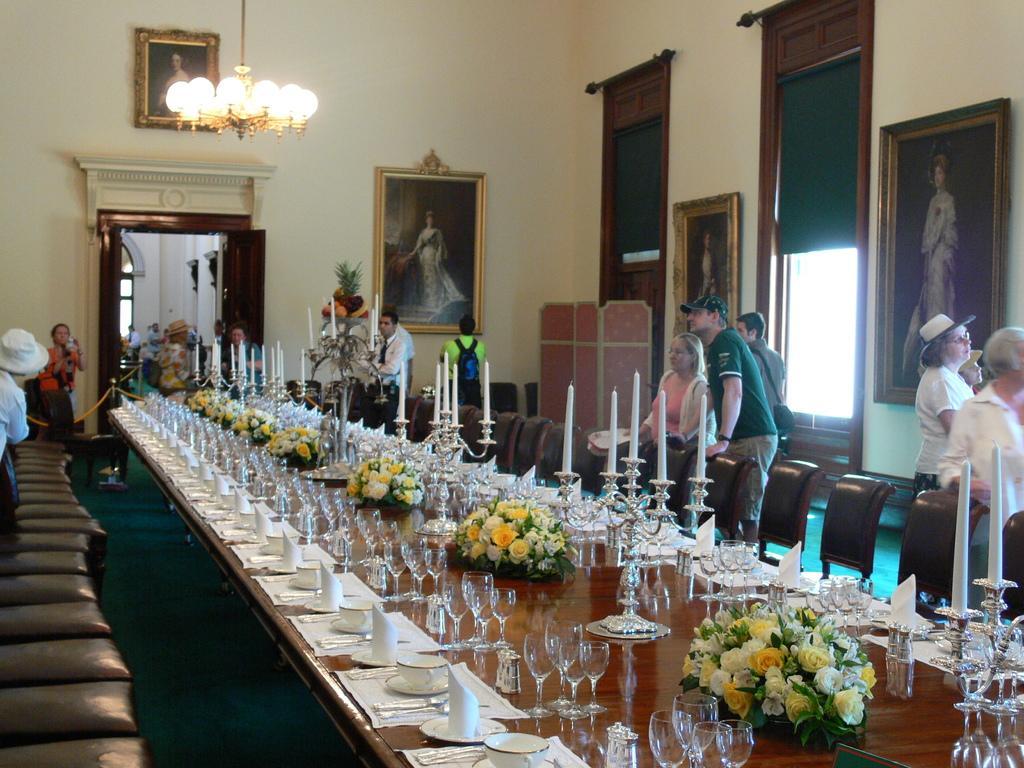Describe this image in one or two sentences. In the picture we can see a people standing near the chair and table. On the table we can find cup, saucers, tissues, glasses and some decorative flowers and candle stand. In the background we can find photo frames, door, wall, to the ceiling we can find lights. 